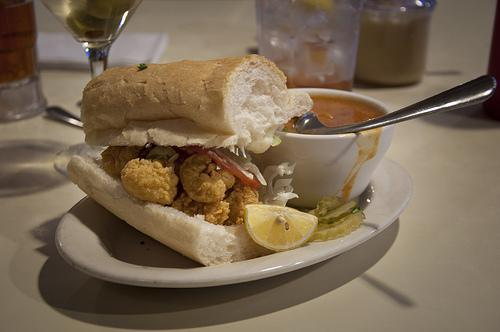Question: how would you eat the soup?
Choices:
A. In a bowl.
B. In a cup.
C. With a spoon.
D. With crackers.
Answer with the letter. Answer: C Question: what color is the table?
Choices:
A. Tan.
B. Brown.
C. Red.
D. White.
Answer with the letter. Answer: A Question: what is running over the bowl?
Choices:
A. Water.
B. Soup.
C. Broth.
D. Sauce.
Answer with the letter. Answer: B Question: where is the spoon?
Choices:
A. On the ice cream.
B. In the dishwasher.
C. In the soup.
D. In the mug.
Answer with the letter. Answer: C Question: what shape is the plate?
Choices:
A. Square.
B. Oval.
C. Rectangle.
D. Pentagon.
Answer with the letter. Answer: B 